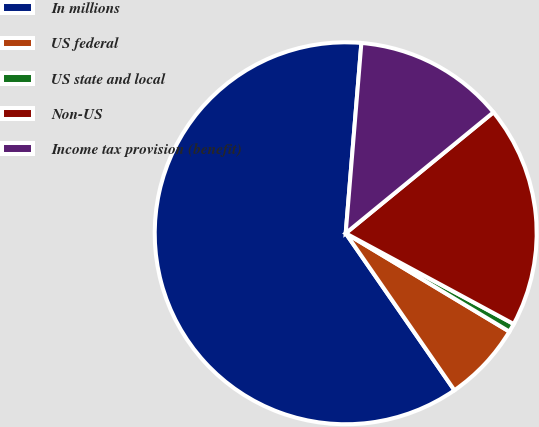Convert chart to OTSL. <chart><loc_0><loc_0><loc_500><loc_500><pie_chart><fcel>In millions<fcel>US federal<fcel>US state and local<fcel>Non-US<fcel>Income tax provision (benefit)<nl><fcel>60.95%<fcel>6.75%<fcel>0.73%<fcel>18.8%<fcel>12.77%<nl></chart> 